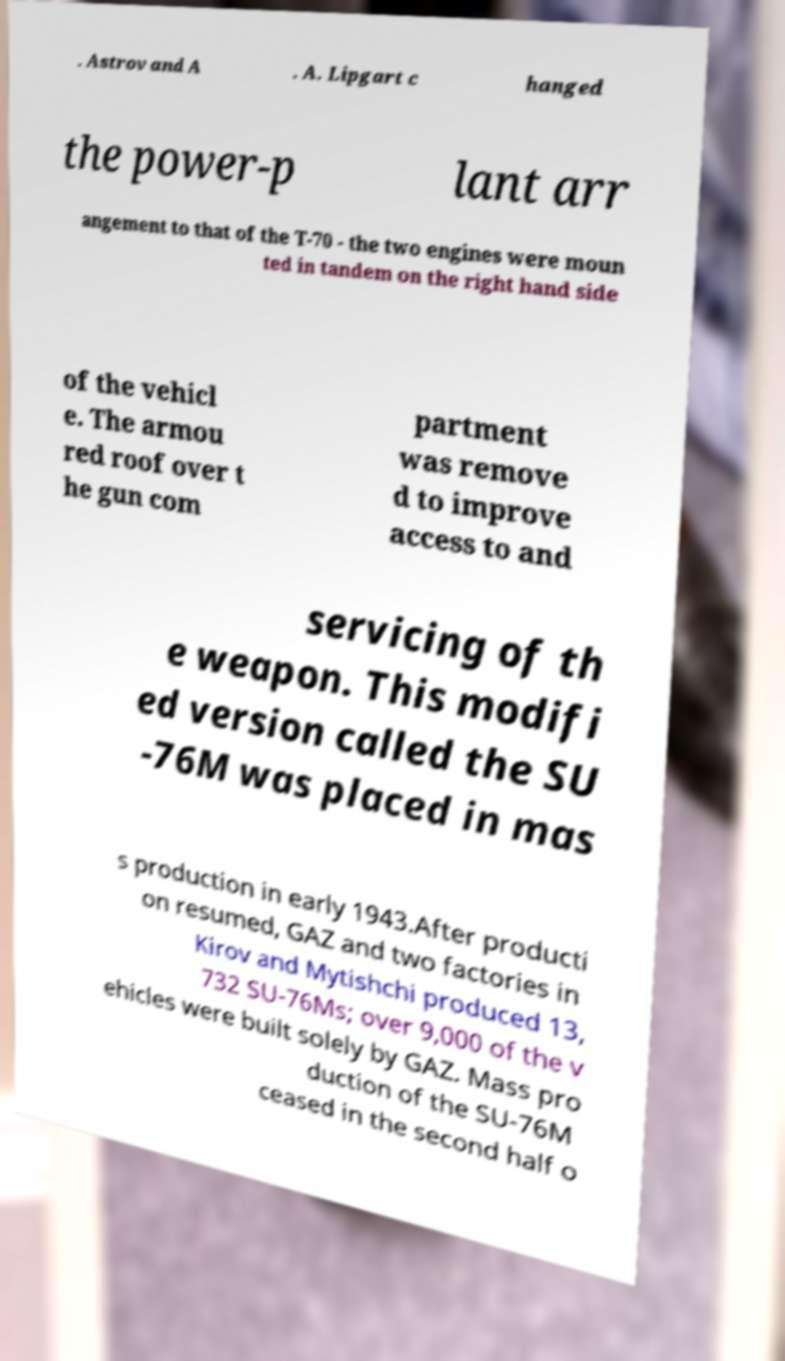Please read and relay the text visible in this image. What does it say? . Astrov and A . A. Lipgart c hanged the power-p lant arr angement to that of the T-70 - the two engines were moun ted in tandem on the right hand side of the vehicl e. The armou red roof over t he gun com partment was remove d to improve access to and servicing of th e weapon. This modifi ed version called the SU -76M was placed in mas s production in early 1943.After producti on resumed, GAZ and two factories in Kirov and Mytishchi produced 13, 732 SU-76Ms; over 9,000 of the v ehicles were built solely by GAZ. Mass pro duction of the SU-76M ceased in the second half o 